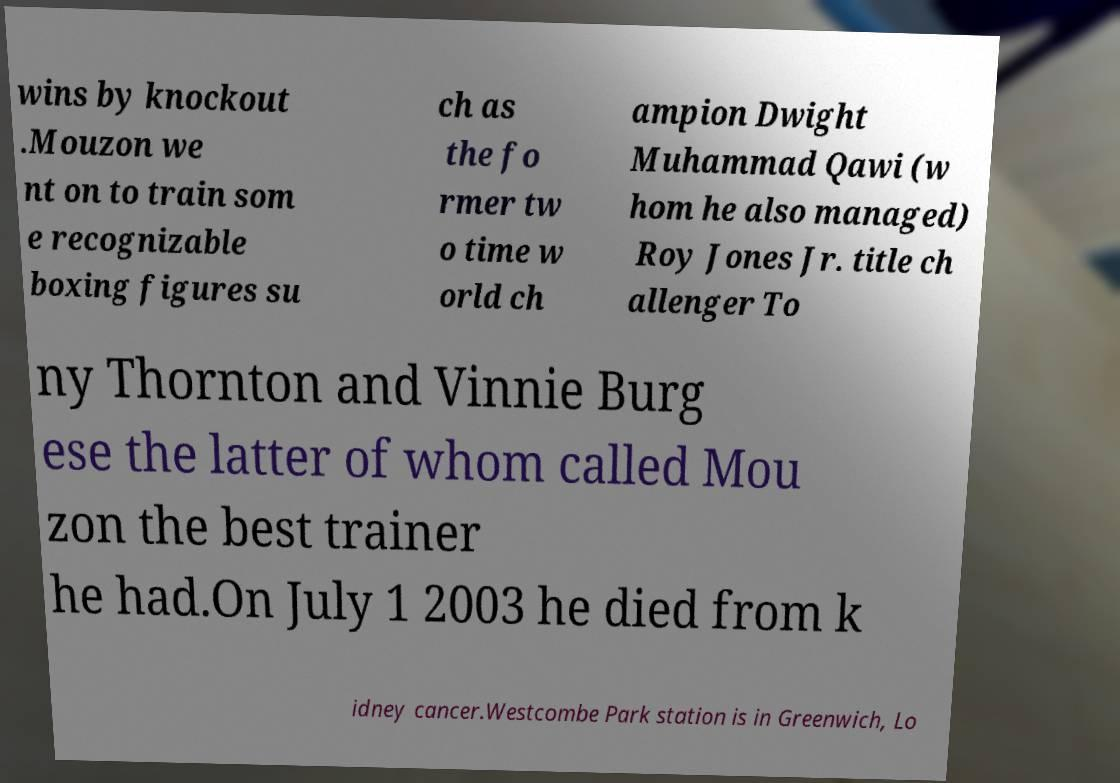What messages or text are displayed in this image? I need them in a readable, typed format. wins by knockout .Mouzon we nt on to train som e recognizable boxing figures su ch as the fo rmer tw o time w orld ch ampion Dwight Muhammad Qawi (w hom he also managed) Roy Jones Jr. title ch allenger To ny Thornton and Vinnie Burg ese the latter of whom called Mou zon the best trainer he had.On July 1 2003 he died from k idney cancer.Westcombe Park station is in Greenwich, Lo 